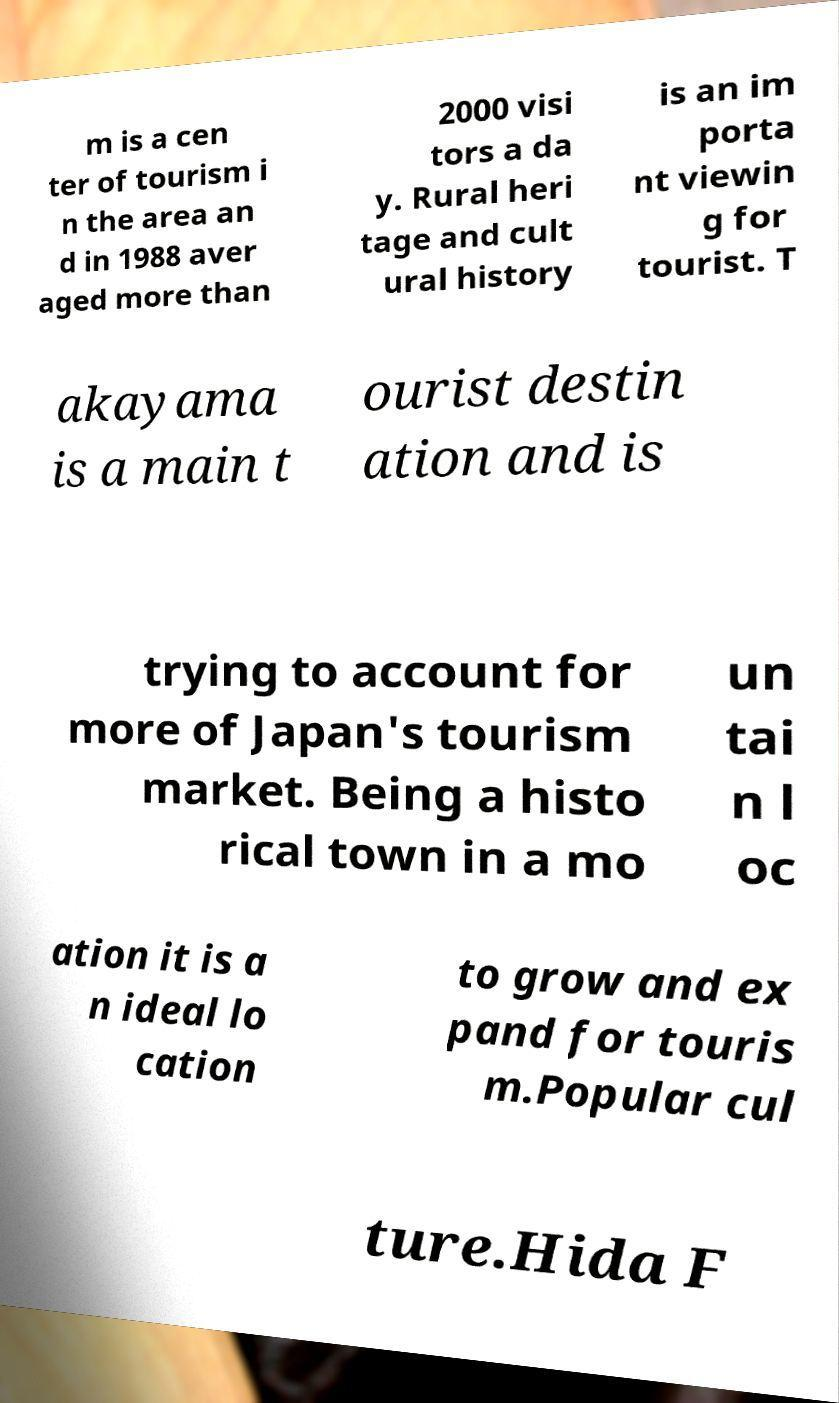Could you assist in decoding the text presented in this image and type it out clearly? m is a cen ter of tourism i n the area an d in 1988 aver aged more than 2000 visi tors a da y. Rural heri tage and cult ural history is an im porta nt viewin g for tourist. T akayama is a main t ourist destin ation and is trying to account for more of Japan's tourism market. Being a histo rical town in a mo un tai n l oc ation it is a n ideal lo cation to grow and ex pand for touris m.Popular cul ture.Hida F 